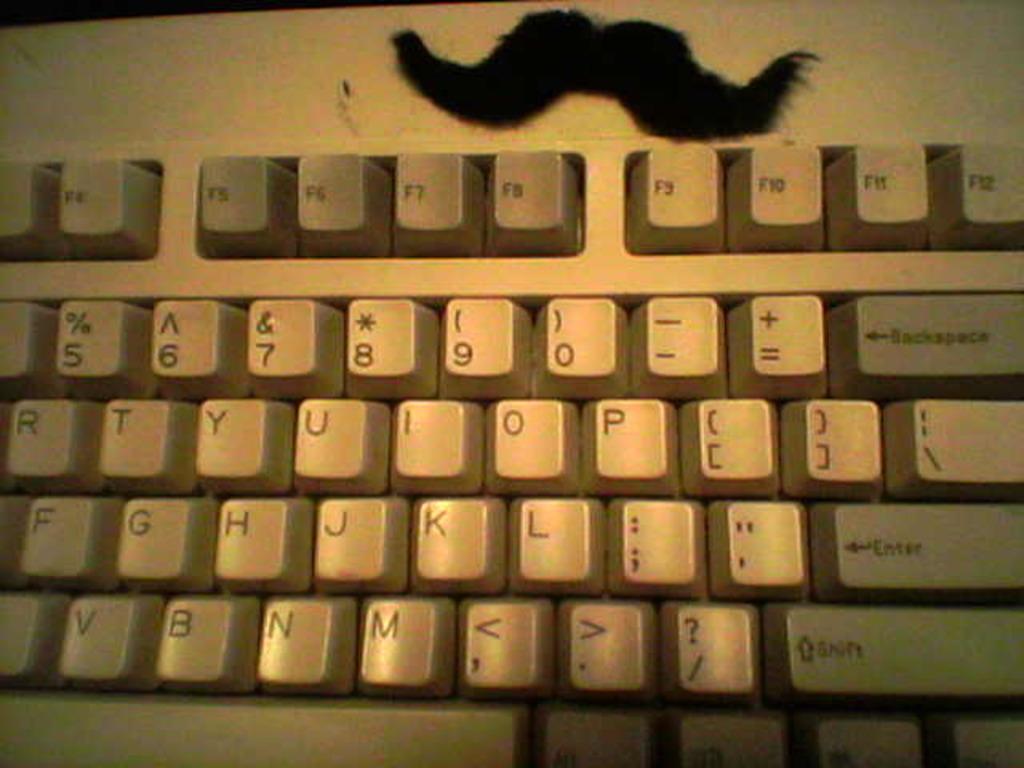Is this a standard keyboard?
Make the answer very short. Yes. What is next to the ?/ key?
Your response must be concise. Shift. 